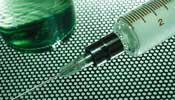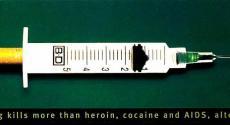The first image is the image on the left, the second image is the image on the right. Analyze the images presented: Is the assertion "A human arm is shown next to a medical instrument" valid? Answer yes or no. No. The first image is the image on the left, the second image is the image on the right. Given the left and right images, does the statement "there is an arm in the image on the left" hold true? Answer yes or no. No. 